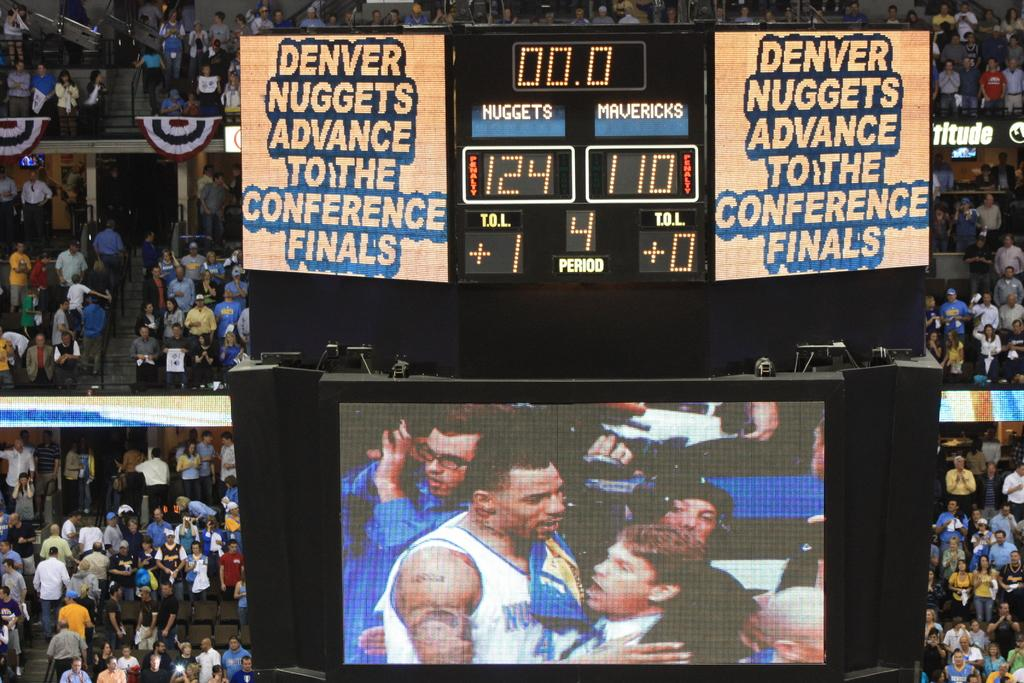<image>
Give a short and clear explanation of the subsequent image. A stadium billboard announces that the Denver Nuggets advance to the conference finals. 